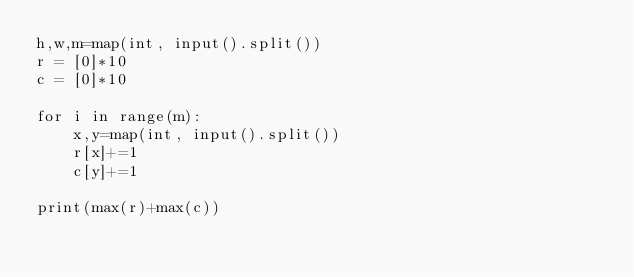Convert code to text. <code><loc_0><loc_0><loc_500><loc_500><_Python_>h,w,m=map(int, input().split())
r = [0]*10
c = [0]*10

for i in range(m):
    x,y=map(int, input().split())
    r[x]+=1
    c[y]+=1

print(max(r)+max(c))</code> 